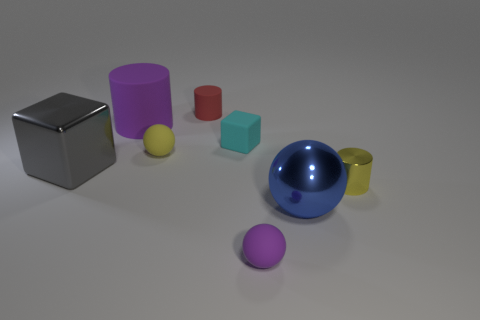The purple rubber object behind the yellow object in front of the tiny yellow rubber thing is what shape?
Your response must be concise. Cylinder. There is a yellow object that is right of the red object; what shape is it?
Your answer should be compact. Cylinder. What number of balls have the same color as the large cylinder?
Your answer should be compact. 1. The large sphere has what color?
Provide a short and direct response. Blue. What number of small cylinders are behind the tiny cylinder that is to the right of the blue shiny thing?
Provide a succinct answer. 1. Is the size of the yellow shiny cylinder the same as the purple matte object that is right of the red rubber object?
Give a very brief answer. Yes. Does the metallic cube have the same size as the yellow matte sphere?
Offer a very short reply. No. Are there any red cylinders that have the same size as the red object?
Keep it short and to the point. No. There is a block that is to the right of the gray thing; what is it made of?
Make the answer very short. Rubber. What is the color of the ball that is the same material as the yellow cylinder?
Give a very brief answer. Blue. 